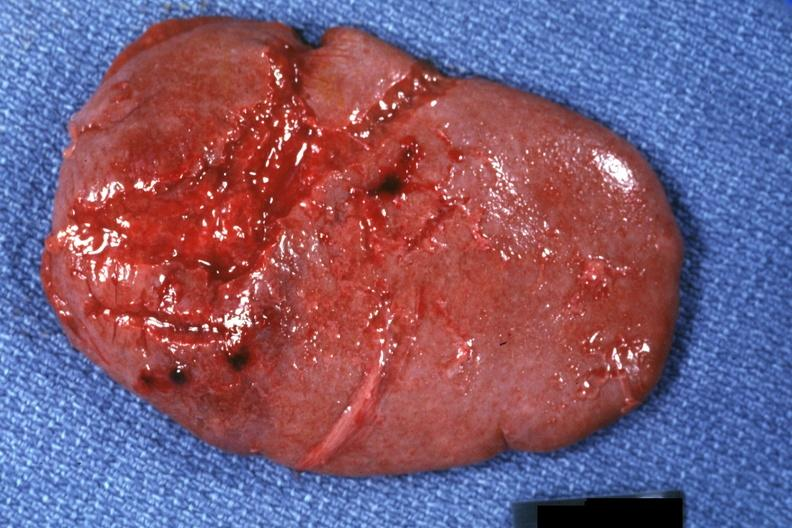s jejunum present?
Answer the question using a single word or phrase. No 